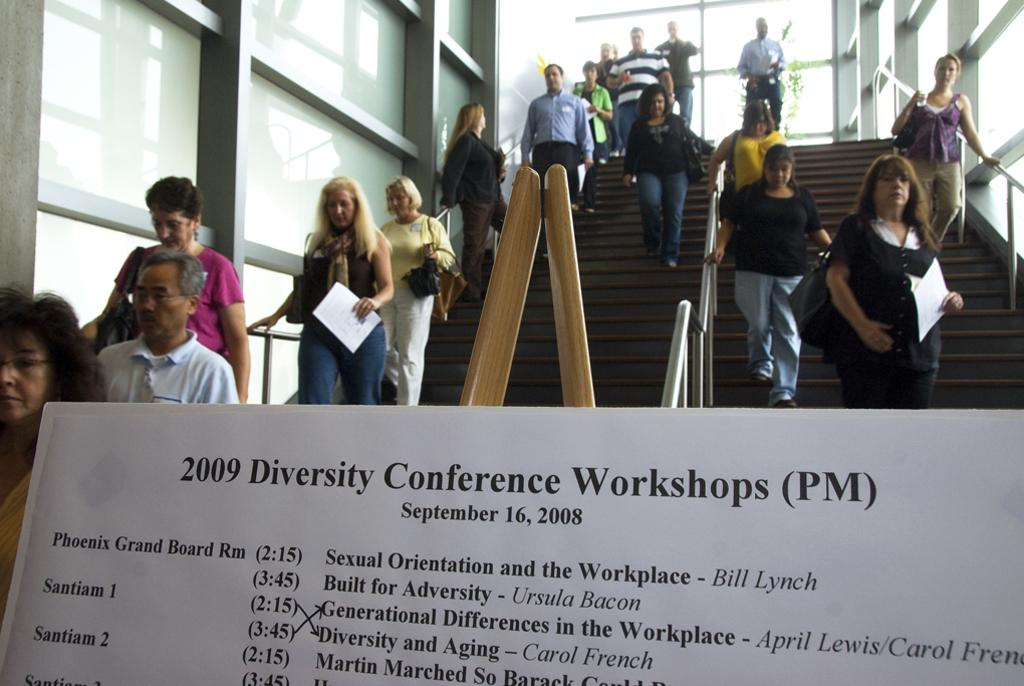What is located at the bottom of the image? There is a notice board at the bottom of the image. What can be seen on the notice board? There is text on the notice board. What material are the rods behind the notice board made of? The rods behind the notice board are made of metal. Can you describe the people present in the image? There are people present in the image, but their specific characteristics are not mentioned in the provided facts. How many eggs are being cooked on the flame in the image? There is no mention of eggs or a flame in the provided facts, so it cannot be determined from the image. 